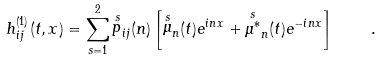<formula> <loc_0><loc_0><loc_500><loc_500>h _ { i j } ^ { ( 1 ) } ( t , { x } ) = \sum _ { s = 1 } ^ { 2 } { \stackrel { s } { p } } _ { i j } ( { n } ) \left [ { \stackrel { s } { \mu } } _ { n } ( t ) e ^ { i { n x } } + { \stackrel { s } { \mu ^ { \ast } } } _ { n } ( t ) e ^ { - i { n x } } \right ] \quad .</formula> 